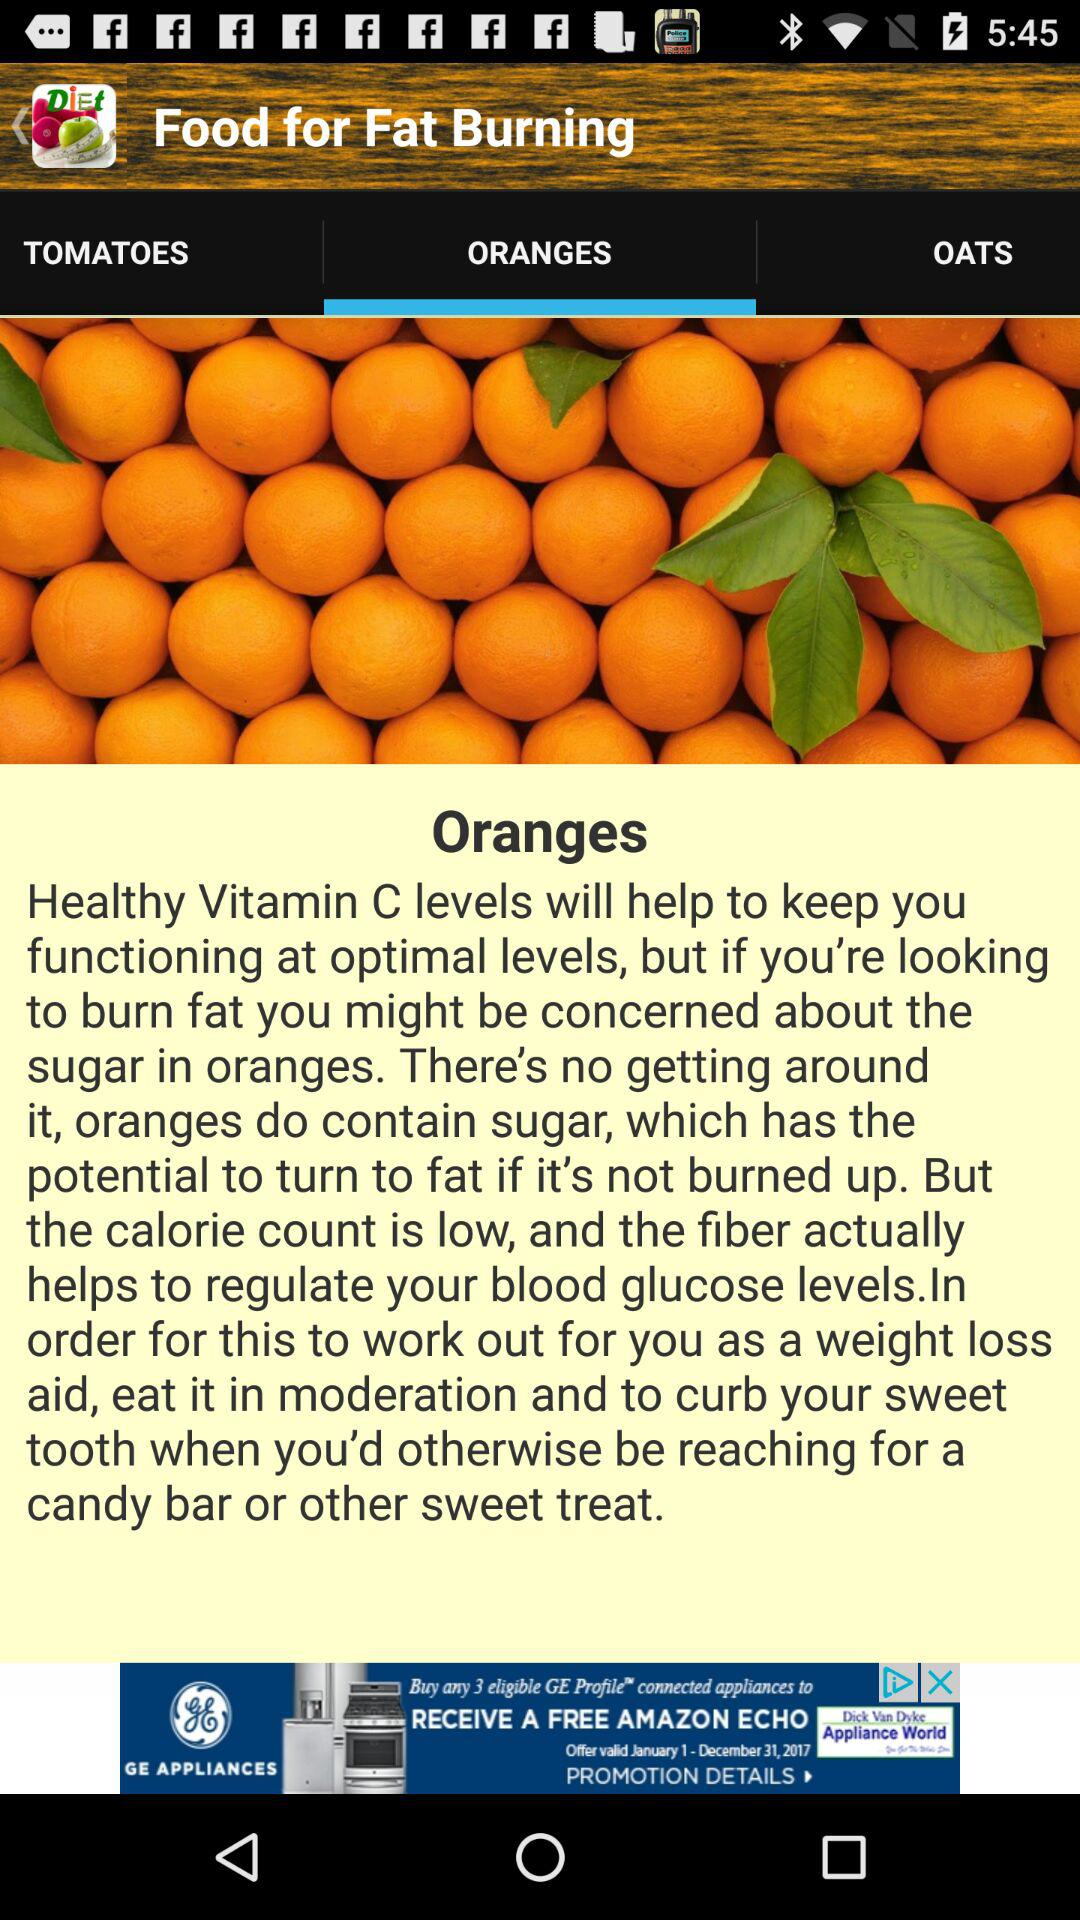What are the fat burning foods? The fat burning foods are "TOMATOES", "ORANGES" and "OATS". 